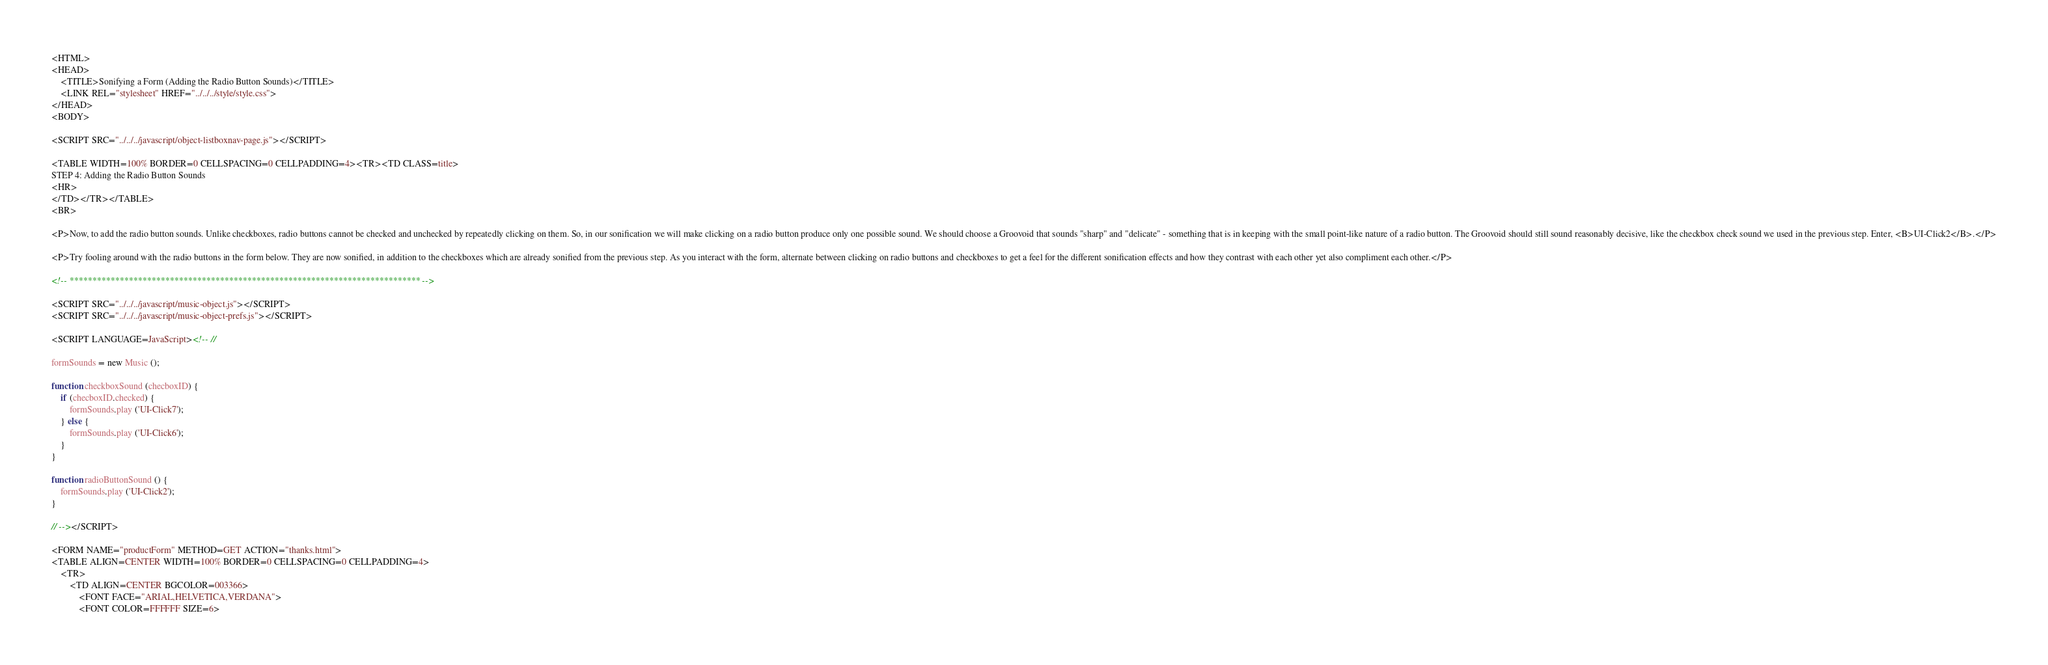Convert code to text. <code><loc_0><loc_0><loc_500><loc_500><_HTML_><HTML>
<HEAD>
	<TITLE>Sonifying a Form (Adding the Radio Button Sounds)</TITLE>
	<LINK REL="stylesheet" HREF="../../../style/style.css">
</HEAD>
<BODY>

<SCRIPT SRC="../../../javascript/object-listboxnav-page.js"></SCRIPT>

<TABLE WIDTH=100% BORDER=0 CELLSPACING=0 CELLPADDING=4><TR><TD CLASS=title>
STEP 4: Adding the Radio Button Sounds
<HR>
</TD></TR></TABLE>
<BR>

<P>Now, to add the radio button sounds. Unlike checkboxes, radio buttons cannot be checked and unchecked by repeatedly clicking on them. So, in our sonification we will make clicking on a radio button produce only one possible sound. We should choose a Groovoid that sounds "sharp" and "delicate" - something that is in keeping with the small point-like nature of a radio button. The Groovoid should still sound reasonably decisive, like the checkbox check sound we used in the previous step. Enter, <B>UI-Click2</B>.</P>

<P>Try fooling around with the radio buttons in the form below. They are now sonified, in addition to the checkboxes which are already sonified from the previous step. As you interact with the form, alternate between clicking on radio buttons and checkboxes to get a feel for the different sonification effects and how they contrast with each other yet also compliment each other.</P>

<!-- ***************************************************************************** -->

<SCRIPT SRC="../../../javascript/music-object.js"></SCRIPT>
<SCRIPT SRC="../../../javascript/music-object-prefs.js"></SCRIPT>

<SCRIPT LANGUAGE=JavaScript><!-- //

formSounds = new Music ();

function checkboxSound (checboxID) {
	if (checboxID.checked) {
		formSounds.play ('UI-Click7');
	} else {
		formSounds.play ('UI-Click6');
	}
}

function radioButtonSound () {
	formSounds.play ('UI-Click2');
}

// --></SCRIPT>

<FORM NAME="productForm" METHOD=GET ACTION="thanks.html">
<TABLE ALIGN=CENTER WIDTH=100% BORDER=0 CELLSPACING=0 CELLPADDING=4>
	<TR>
		<TD ALIGN=CENTER BGCOLOR=003366>
			<FONT FACE="ARIAL,HELVETICA,VERDANA">
			<FONT COLOR=FFFFFF SIZE=6></code> 